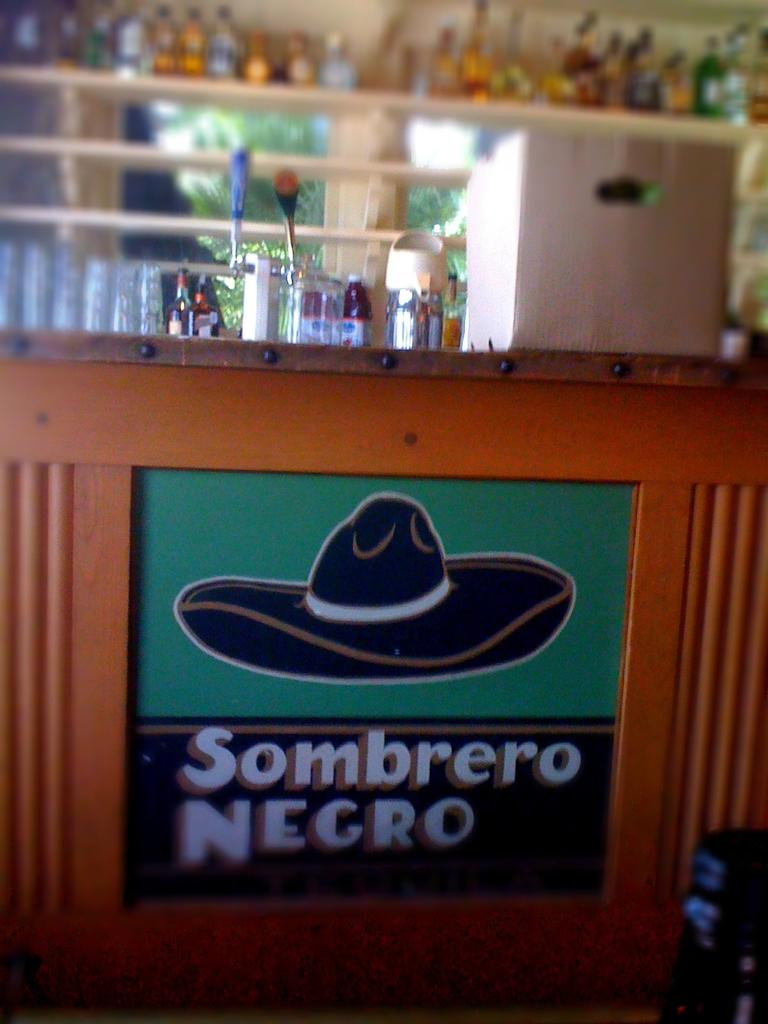Provide a one-sentence caption for the provided image. a table with a sign that says sombrero negro with a drawn on black hat. 